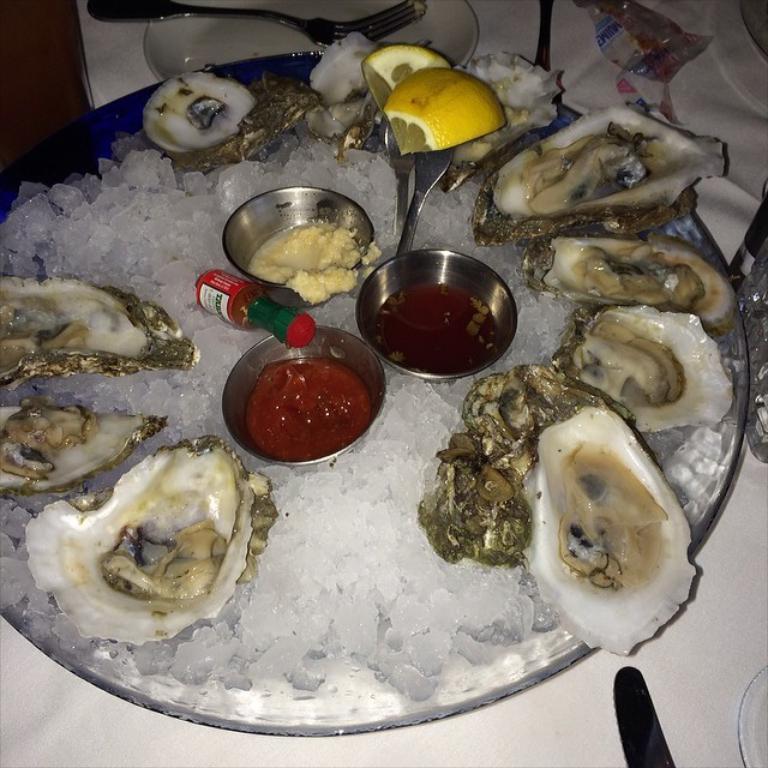Describe this image in one or two sentences. In this image there is a table and we can see plates, forks and a tray containing crushed ice, oysters, condiments and lemon slices placed on the table. 